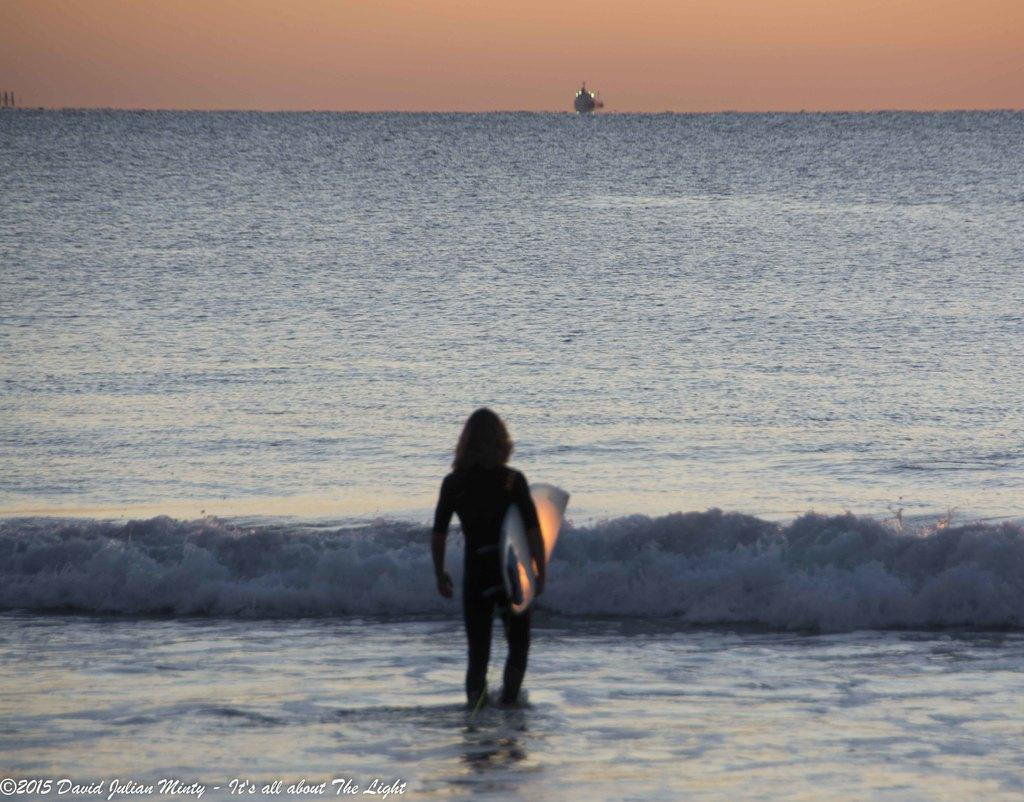Who or what is present in the image? There is a person in the image. What is the person holding in the image? The person is holding a rowboat. Where is the person standing in the image? The person is standing near the ocean. What type of tax is being discussed in the image? There is no mention of tax in the image, as it features a person holding a rowboat near the ocean. 